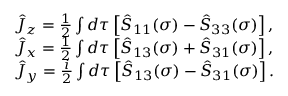Convert formula to latex. <formula><loc_0><loc_0><loc_500><loc_500>\begin{array} { r l } & { \hat { J } _ { z } = \frac { 1 } { 2 } \int d \tau \left [ \hat { S } _ { 1 1 } ( \sigma ) - \hat { S } _ { 3 3 } ( \sigma ) \right ] , } \\ & { \hat { J } _ { x } = \frac { 1 } { 2 } \int d \tau \left [ \hat { S } _ { 1 3 } ( \sigma ) + \hat { S } _ { 3 1 } ( \sigma ) \right ] , } \\ & { \hat { J } _ { y } = \frac { i } { 2 } \int d \tau \left [ \hat { S } _ { 1 3 } ( \sigma ) - \hat { S } _ { 3 1 } ( \sigma ) \right ] . } \end{array}</formula> 